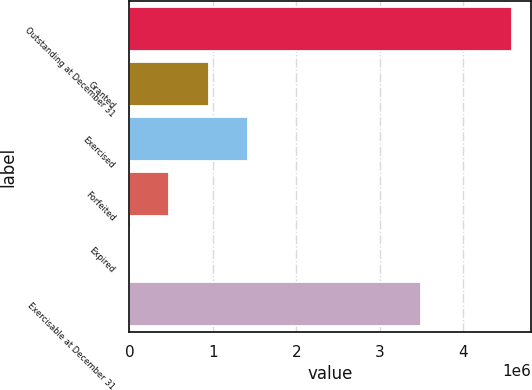<chart> <loc_0><loc_0><loc_500><loc_500><bar_chart><fcel>Outstanding at December 31<fcel>Granted<fcel>Exercised<fcel>Forfeited<fcel>Expired<fcel>Exercisable at December 31<nl><fcel>4.58424e+06<fcel>949193<fcel>1.42172e+06<fcel>476667<fcel>4141<fcel>3.49649e+06<nl></chart> 